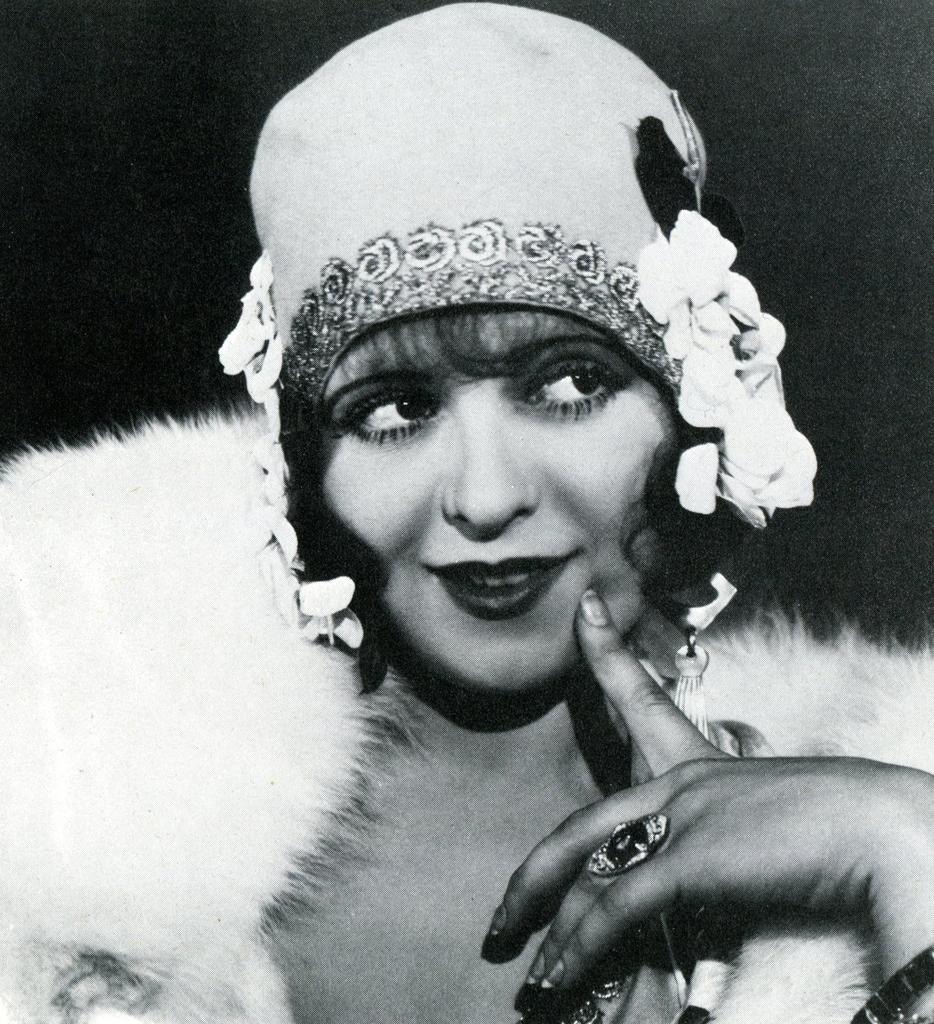What is the main subject of the image? The main subject of the image is a woman. What is the woman doing in the image? The woman is smiling in the image. What is the woman wearing on her head? The woman is wearing headgear in the image. What is the color scheme of the image? The image is in black and white. What is the reason for the roof being so high in the image? There is no roof present in the image, as it features a woman wearing headgear and the image is in black and white. 